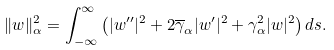Convert formula to latex. <formula><loc_0><loc_0><loc_500><loc_500>\| w \| ^ { 2 } _ { \alpha } = \int _ { - \infty } ^ { \infty } \left ( | w ^ { \prime \prime } | ^ { 2 } + 2 \overline { \gamma } _ { \alpha } | w ^ { \prime } | ^ { 2 } + \gamma _ { \alpha } ^ { 2 } | w | ^ { 2 } \right ) d s .</formula> 